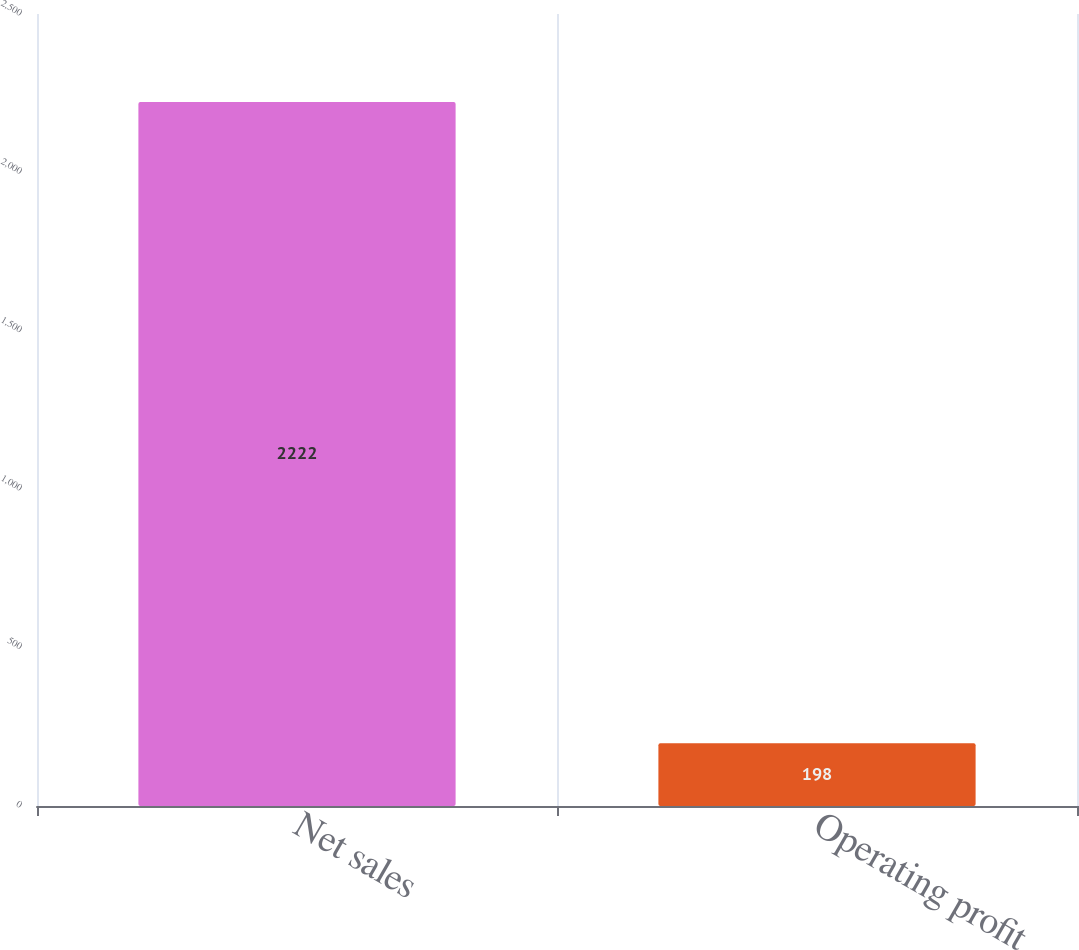<chart> <loc_0><loc_0><loc_500><loc_500><bar_chart><fcel>Net sales<fcel>Operating profit<nl><fcel>2222<fcel>198<nl></chart> 